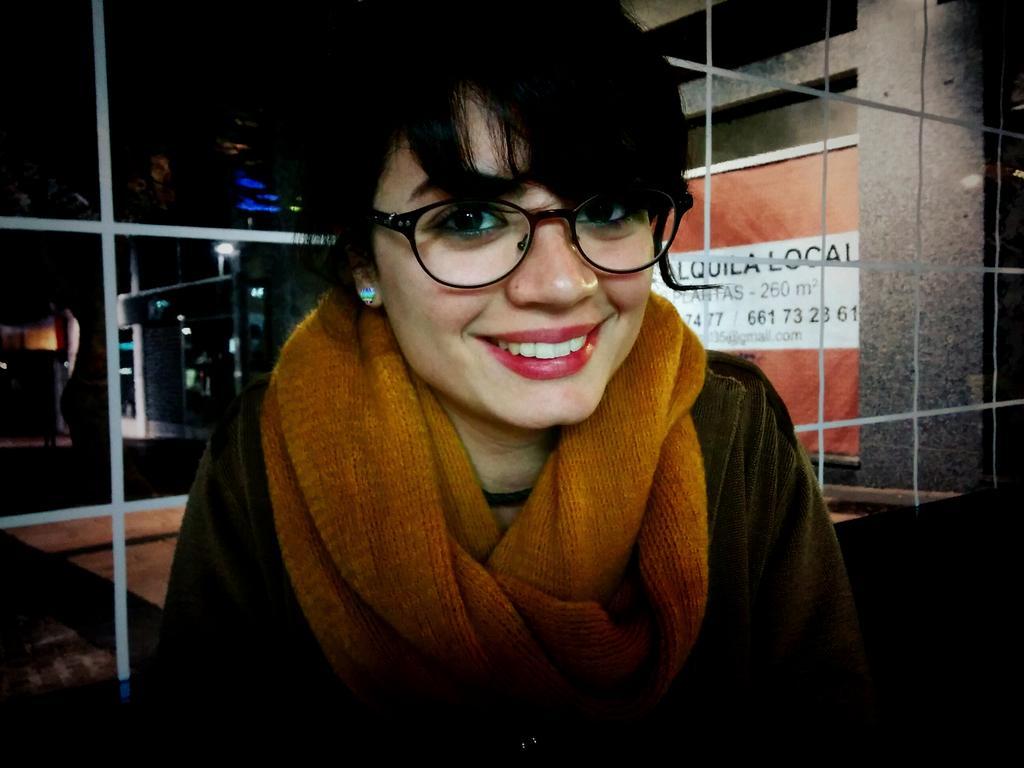Could you give a brief overview of what you see in this image? Here I can see a woman is smiling and looking at the picture. At the back of her there is a glass through which we can see the outside view. In the background there is a building in the dark. On the right side there is a banner attached to the wall. 